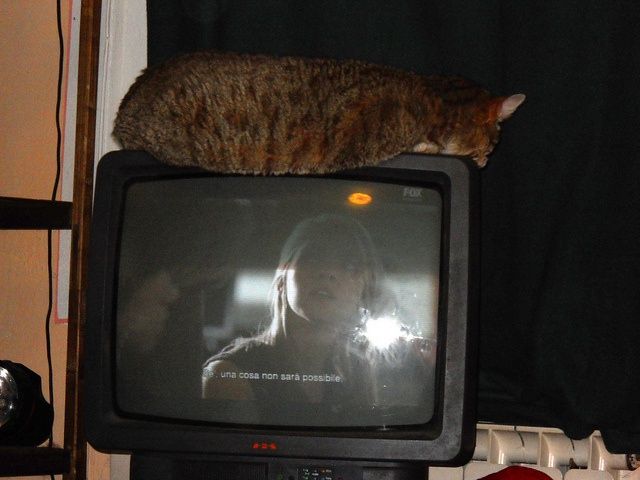Describe the objects in this image and their specific colors. I can see tv in gray, black, and darkgray tones, cat in gray, black, and maroon tones, and people in gray, black, and darkgray tones in this image. 